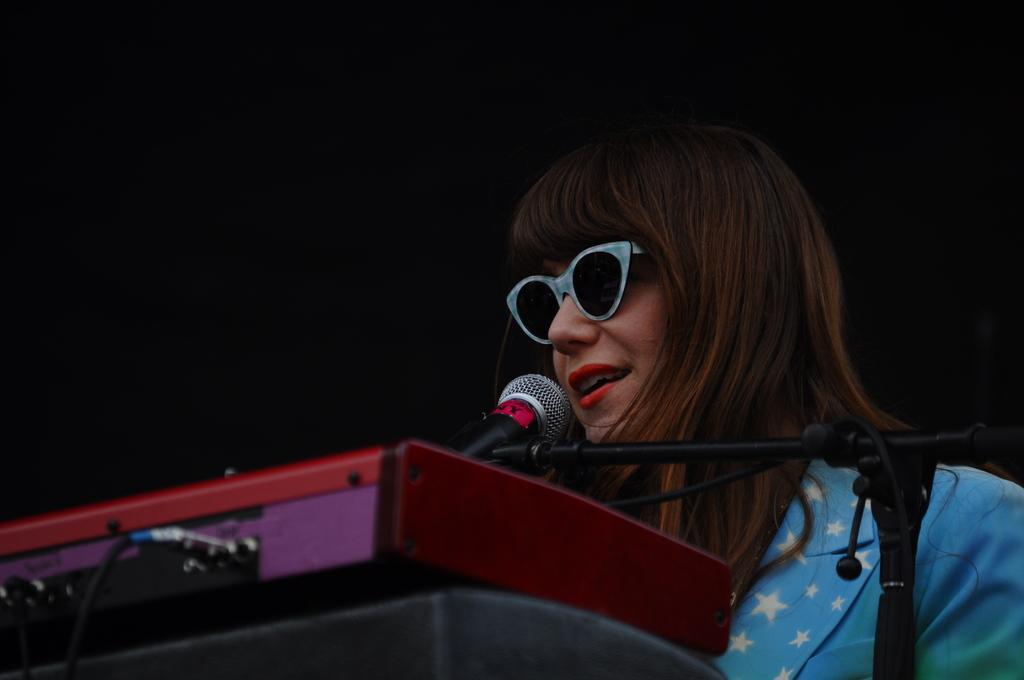In one or two sentences, can you explain what this image depicts? In the center of the image we can see person standing at the mic. At the bottom of the image we can see keyboard. 